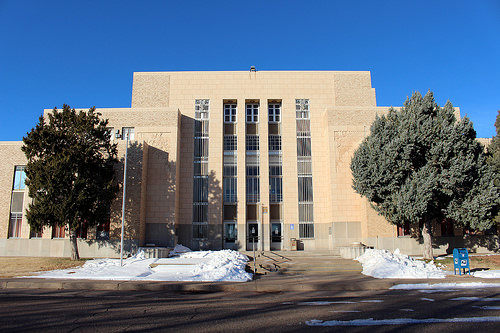<image>
Can you confirm if the tree is under the building? No. The tree is not positioned under the building. The vertical relationship between these objects is different. 